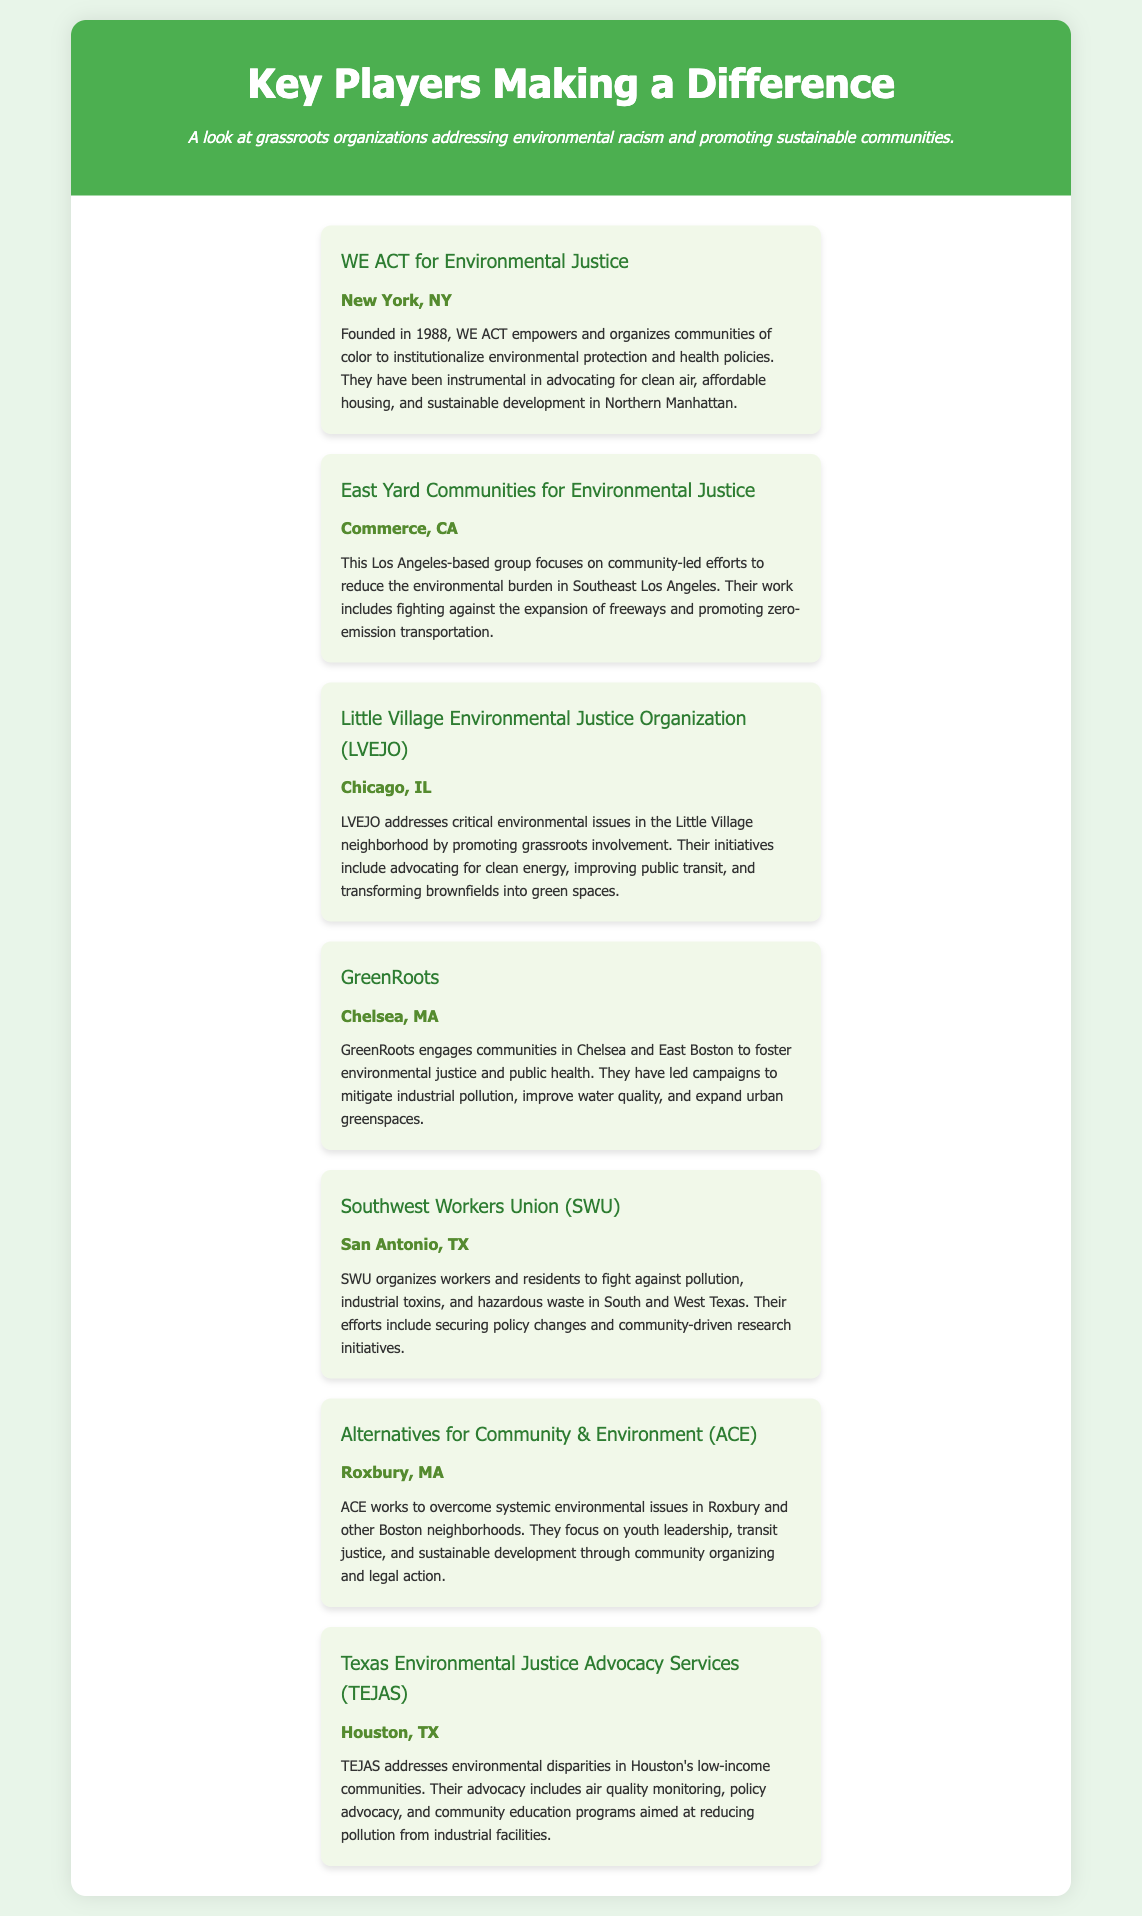what is the name of the organization based in New York? The document lists "WE ACT for Environmental Justice" as the organization based in New York, NY.
Answer: WE ACT for Environmental Justice how many years has GreenRoots been active? GreenRoots is mentioned as engaging communities since its foundation, but the document does not specify the year it was founded. Therefore, the number of active years cannot be determined from this document.
Answer: Not specified which organization focuses on Texas? The document lists "Southwest Workers Union" and "Texas Environmental Justice Advocacy Services" as organizations that focus on Texas.
Answer: Southwest Workers Union, Texas Environmental Justice Advocacy Services what is the main focus of the Little Village Environmental Justice Organization? The main focus of LVEJO is to address critical environmental issues in the Little Village neighborhood, promoting grassroots involvement and advocating for clean energy.
Answer: Clean energy, public transit, green spaces where is the East Yard Communities for Environmental Justice located? The document states that East Yard Communities for Environmental Justice is located in Commerce, CA.
Answer: Commerce, CA which organization is known for youth leadership work? The document specifies that Alternatives for Community & Environment (ACE) works on youth leadership, transit justice, and sustainable development.
Answer: Alternatives for Community & Environment what is the location of the organization that fights pollution and industrial toxins? The organization that fights pollution and industrial toxins, "Southwest Workers Union," is located in San Antonio, TX.
Answer: San Antonio, TX which organization has been instrumental in advocating for clean air and affordable housing? The document mentions that WE ACT for Environmental Justice has been instrumental in advocating for clean air and affordable housing.
Answer: WE ACT for Environmental Justice 